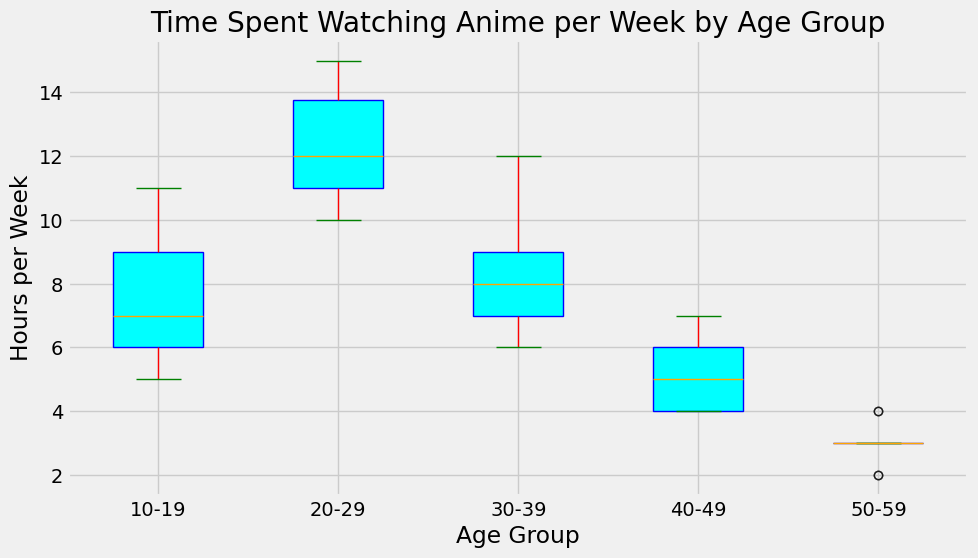What is the median time spent watching anime per week for the 10-19 age group? The box plot shows the median as a line inside the box. For the 10-19 age group, locate the position of the median line within the box.
Answer: 7 Which age group spends the most time watching anime per week on average? To determine this, compare the median lines across the different age groups. The median is the best indicator of average time. Look for the highest median value.
Answer: 20-29 What is the range of time spent watching anime in the 30-39 age group? The range is determined by the distance between the bottom whisker (minimum) and the top whisker (maximum). For the 30-39 age group, locate these points on the plot.
Answer: 6-12 Is there an age group that watches less anime per week than the others? Compare the medians and the interquartile ranges of all age groups. The group with the lowest median and smallest range spends less time on average.
Answer: 50-59 How do the interquartile ranges (IQR) of the 20-29 and 40-49 age groups compare? The IQR is the range between the first quartile (bottom of the box) and the third quartile (top of the box). For the 20-29 and 40-49 age groups, visually compare the lengths of the boxes.
Answer: 20-29 has a larger IQR than 40-49 Which age group shows the greatest variability in time spent watching anime per week? Variability can be assessed by the length of the whiskers and the size of the interquartile range. Identify which age group has the widest overall spread in their box plot.
Answer: 20-29 Does any age group have outliers in their anime watching times? Outliers are typically marked by points outside of the whiskers. Examine each age group’s box plot for any points that lie beyond the whiskers.
Answer: No Can you rank the age groups from highest to lowest based on their median watching time? Look at the median lines (middle lines in the boxes) for each age group and arrange them from highest to lowest.
Answer: 20-29, 10-19, 30-39, 40-49, 50-59 What is the upper quartile value for the 40-49 age group? The upper quartile is the value at the top of the box (75th percentile). For the 40-49 age group, read off this value directly from the box plot.
Answer: 6 Are the boxes for the 10-19 and 30-39 age groups similarly sized? Compare the heights of the boxes for the 10-19 and 30-39 age groups. This gives an indication of the interquartile range for each group.
Answer: Yes 